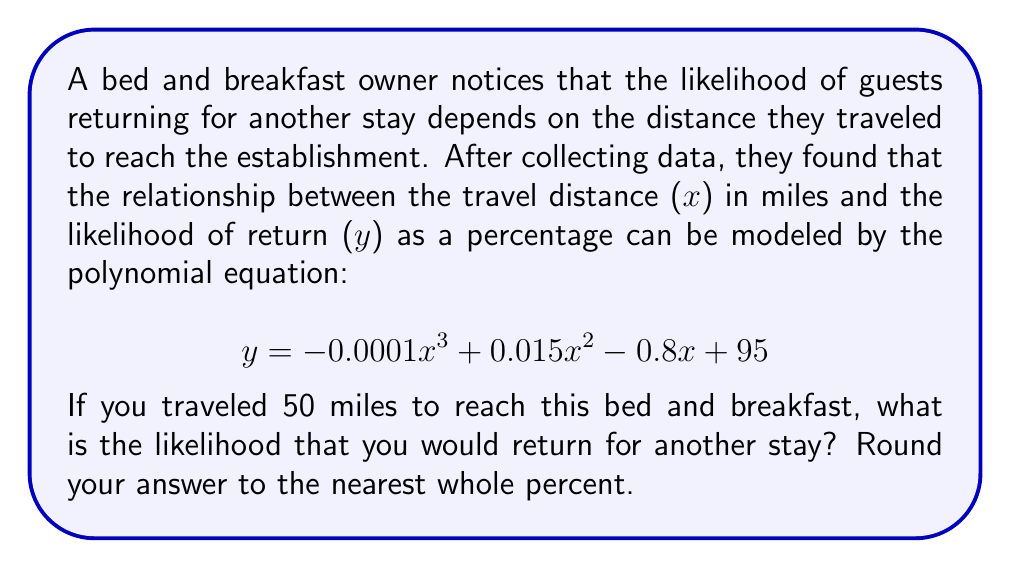Can you answer this question? To solve this problem, we need to substitute the given travel distance (x = 50 miles) into the polynomial equation and calculate the result.

1. Start with the given equation:
   $$ y = -0.0001x^3 + 0.015x^2 - 0.8x + 95 $$

2. Substitute x = 50:
   $$ y = -0.0001(50)^3 + 0.015(50)^2 - 0.8(50) + 95 $$

3. Calculate each term:
   - $-0.0001(50)^3 = -0.0001 * 125000 = -12.5$
   - $0.015(50)^2 = 0.015 * 2500 = 37.5$
   - $-0.8(50) = -40$
   - The constant term is already 95

4. Sum up all the terms:
   $$ y = -12.5 + 37.5 - 40 + 95 = 80 $$

5. Round to the nearest whole percent:
   80% (no rounding needed in this case)

Therefore, if you traveled 50 miles to reach this bed and breakfast, the likelihood of returning for another stay is 80%.
Answer: 80% 